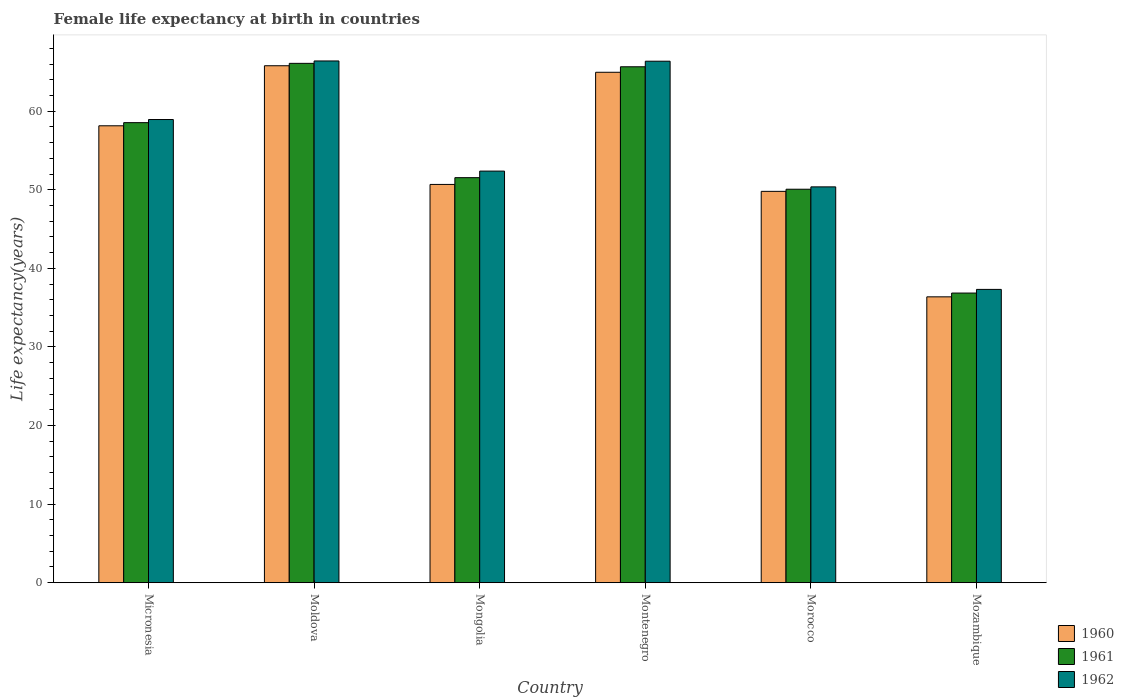How many bars are there on the 3rd tick from the right?
Your answer should be very brief. 3. What is the label of the 6th group of bars from the left?
Offer a very short reply. Mozambique. In how many cases, is the number of bars for a given country not equal to the number of legend labels?
Provide a short and direct response. 0. What is the female life expectancy at birth in 1962 in Moldova?
Your response must be concise. 66.4. Across all countries, what is the maximum female life expectancy at birth in 1962?
Your answer should be very brief. 66.4. Across all countries, what is the minimum female life expectancy at birth in 1960?
Make the answer very short. 36.38. In which country was the female life expectancy at birth in 1961 maximum?
Make the answer very short. Moldova. In which country was the female life expectancy at birth in 1960 minimum?
Your answer should be compact. Mozambique. What is the total female life expectancy at birth in 1961 in the graph?
Offer a very short reply. 328.79. What is the difference between the female life expectancy at birth in 1960 in Mongolia and that in Morocco?
Your response must be concise. 0.88. What is the difference between the female life expectancy at birth in 1960 in Micronesia and the female life expectancy at birth in 1961 in Montenegro?
Make the answer very short. -7.51. What is the average female life expectancy at birth in 1961 per country?
Keep it short and to the point. 54.8. What is the difference between the female life expectancy at birth of/in 1961 and female life expectancy at birth of/in 1962 in Montenegro?
Your response must be concise. -0.71. In how many countries, is the female life expectancy at birth in 1961 greater than 66 years?
Offer a very short reply. 1. What is the ratio of the female life expectancy at birth in 1960 in Micronesia to that in Montenegro?
Your answer should be compact. 0.9. Is the female life expectancy at birth in 1960 in Morocco less than that in Mozambique?
Make the answer very short. No. Is the difference between the female life expectancy at birth in 1961 in Micronesia and Mozambique greater than the difference between the female life expectancy at birth in 1962 in Micronesia and Mozambique?
Ensure brevity in your answer.  Yes. What is the difference between the highest and the second highest female life expectancy at birth in 1960?
Make the answer very short. -0.83. What is the difference between the highest and the lowest female life expectancy at birth in 1962?
Ensure brevity in your answer.  29.07. What does the 1st bar from the right in Mozambique represents?
Offer a terse response. 1962. Is it the case that in every country, the sum of the female life expectancy at birth in 1961 and female life expectancy at birth in 1960 is greater than the female life expectancy at birth in 1962?
Your answer should be very brief. Yes. How many bars are there?
Your response must be concise. 18. Are all the bars in the graph horizontal?
Provide a succinct answer. No. What is the difference between two consecutive major ticks on the Y-axis?
Offer a very short reply. 10. Are the values on the major ticks of Y-axis written in scientific E-notation?
Make the answer very short. No. Where does the legend appear in the graph?
Your response must be concise. Bottom right. What is the title of the graph?
Make the answer very short. Female life expectancy at birth in countries. What is the label or title of the X-axis?
Ensure brevity in your answer.  Country. What is the label or title of the Y-axis?
Give a very brief answer. Life expectancy(years). What is the Life expectancy(years) in 1960 in Micronesia?
Offer a very short reply. 58.15. What is the Life expectancy(years) of 1961 in Micronesia?
Provide a succinct answer. 58.55. What is the Life expectancy(years) of 1962 in Micronesia?
Keep it short and to the point. 58.95. What is the Life expectancy(years) in 1960 in Moldova?
Your response must be concise. 65.79. What is the Life expectancy(years) of 1961 in Moldova?
Offer a terse response. 66.1. What is the Life expectancy(years) of 1962 in Moldova?
Your response must be concise. 66.4. What is the Life expectancy(years) of 1960 in Mongolia?
Ensure brevity in your answer.  50.69. What is the Life expectancy(years) of 1961 in Mongolia?
Provide a short and direct response. 51.55. What is the Life expectancy(years) of 1962 in Mongolia?
Offer a very short reply. 52.38. What is the Life expectancy(years) in 1960 in Montenegro?
Ensure brevity in your answer.  64.96. What is the Life expectancy(years) in 1961 in Montenegro?
Give a very brief answer. 65.66. What is the Life expectancy(years) of 1962 in Montenegro?
Your response must be concise. 66.37. What is the Life expectancy(years) of 1960 in Morocco?
Give a very brief answer. 49.81. What is the Life expectancy(years) of 1961 in Morocco?
Give a very brief answer. 50.08. What is the Life expectancy(years) of 1962 in Morocco?
Give a very brief answer. 50.38. What is the Life expectancy(years) in 1960 in Mozambique?
Your answer should be very brief. 36.38. What is the Life expectancy(years) in 1961 in Mozambique?
Your answer should be very brief. 36.86. What is the Life expectancy(years) of 1962 in Mozambique?
Ensure brevity in your answer.  37.33. Across all countries, what is the maximum Life expectancy(years) of 1960?
Make the answer very short. 65.79. Across all countries, what is the maximum Life expectancy(years) of 1961?
Make the answer very short. 66.1. Across all countries, what is the maximum Life expectancy(years) in 1962?
Make the answer very short. 66.4. Across all countries, what is the minimum Life expectancy(years) in 1960?
Ensure brevity in your answer.  36.38. Across all countries, what is the minimum Life expectancy(years) of 1961?
Make the answer very short. 36.86. Across all countries, what is the minimum Life expectancy(years) of 1962?
Your response must be concise. 37.33. What is the total Life expectancy(years) in 1960 in the graph?
Give a very brief answer. 325.78. What is the total Life expectancy(years) of 1961 in the graph?
Keep it short and to the point. 328.79. What is the total Life expectancy(years) of 1962 in the graph?
Your answer should be compact. 331.8. What is the difference between the Life expectancy(years) of 1960 in Micronesia and that in Moldova?
Provide a succinct answer. -7.64. What is the difference between the Life expectancy(years) of 1961 in Micronesia and that in Moldova?
Offer a very short reply. -7.55. What is the difference between the Life expectancy(years) of 1962 in Micronesia and that in Moldova?
Make the answer very short. -7.45. What is the difference between the Life expectancy(years) of 1960 in Micronesia and that in Mongolia?
Your answer should be very brief. 7.46. What is the difference between the Life expectancy(years) of 1961 in Micronesia and that in Mongolia?
Give a very brief answer. 7. What is the difference between the Life expectancy(years) of 1962 in Micronesia and that in Mongolia?
Your response must be concise. 6.56. What is the difference between the Life expectancy(years) of 1960 in Micronesia and that in Montenegro?
Give a very brief answer. -6.81. What is the difference between the Life expectancy(years) in 1961 in Micronesia and that in Montenegro?
Ensure brevity in your answer.  -7.11. What is the difference between the Life expectancy(years) in 1962 in Micronesia and that in Montenegro?
Ensure brevity in your answer.  -7.42. What is the difference between the Life expectancy(years) of 1960 in Micronesia and that in Morocco?
Give a very brief answer. 8.34. What is the difference between the Life expectancy(years) of 1961 in Micronesia and that in Morocco?
Keep it short and to the point. 8.47. What is the difference between the Life expectancy(years) in 1962 in Micronesia and that in Morocco?
Ensure brevity in your answer.  8.57. What is the difference between the Life expectancy(years) in 1960 in Micronesia and that in Mozambique?
Ensure brevity in your answer.  21.77. What is the difference between the Life expectancy(years) in 1961 in Micronesia and that in Mozambique?
Ensure brevity in your answer.  21.69. What is the difference between the Life expectancy(years) of 1962 in Micronesia and that in Mozambique?
Offer a terse response. 21.62. What is the difference between the Life expectancy(years) of 1960 in Moldova and that in Mongolia?
Offer a very short reply. 15.1. What is the difference between the Life expectancy(years) of 1961 in Moldova and that in Mongolia?
Make the answer very short. 14.55. What is the difference between the Life expectancy(years) in 1962 in Moldova and that in Mongolia?
Your answer should be very brief. 14.02. What is the difference between the Life expectancy(years) in 1960 in Moldova and that in Montenegro?
Your response must be concise. 0.83. What is the difference between the Life expectancy(years) of 1961 in Moldova and that in Montenegro?
Provide a short and direct response. 0.43. What is the difference between the Life expectancy(years) of 1962 in Moldova and that in Montenegro?
Your answer should be very brief. 0.03. What is the difference between the Life expectancy(years) in 1960 in Moldova and that in Morocco?
Ensure brevity in your answer.  15.98. What is the difference between the Life expectancy(years) in 1961 in Moldova and that in Morocco?
Your answer should be compact. 16.02. What is the difference between the Life expectancy(years) of 1962 in Moldova and that in Morocco?
Keep it short and to the point. 16.02. What is the difference between the Life expectancy(years) in 1960 in Moldova and that in Mozambique?
Your answer should be compact. 29.41. What is the difference between the Life expectancy(years) in 1961 in Moldova and that in Mozambique?
Provide a short and direct response. 29.23. What is the difference between the Life expectancy(years) in 1962 in Moldova and that in Mozambique?
Provide a short and direct response. 29.07. What is the difference between the Life expectancy(years) in 1960 in Mongolia and that in Montenegro?
Make the answer very short. -14.27. What is the difference between the Life expectancy(years) in 1961 in Mongolia and that in Montenegro?
Provide a short and direct response. -14.11. What is the difference between the Life expectancy(years) of 1962 in Mongolia and that in Montenegro?
Ensure brevity in your answer.  -13.98. What is the difference between the Life expectancy(years) in 1960 in Mongolia and that in Morocco?
Make the answer very short. 0.88. What is the difference between the Life expectancy(years) in 1961 in Mongolia and that in Morocco?
Ensure brevity in your answer.  1.47. What is the difference between the Life expectancy(years) of 1962 in Mongolia and that in Morocco?
Your answer should be compact. 2.01. What is the difference between the Life expectancy(years) in 1960 in Mongolia and that in Mozambique?
Your answer should be compact. 14.31. What is the difference between the Life expectancy(years) of 1961 in Mongolia and that in Mozambique?
Your answer should be compact. 14.69. What is the difference between the Life expectancy(years) of 1962 in Mongolia and that in Mozambique?
Offer a terse response. 15.05. What is the difference between the Life expectancy(years) in 1960 in Montenegro and that in Morocco?
Offer a very short reply. 15.15. What is the difference between the Life expectancy(years) of 1961 in Montenegro and that in Morocco?
Your answer should be very brief. 15.58. What is the difference between the Life expectancy(years) of 1962 in Montenegro and that in Morocco?
Ensure brevity in your answer.  15.99. What is the difference between the Life expectancy(years) in 1960 in Montenegro and that in Mozambique?
Make the answer very short. 28.58. What is the difference between the Life expectancy(years) in 1961 in Montenegro and that in Mozambique?
Your response must be concise. 28.8. What is the difference between the Life expectancy(years) of 1962 in Montenegro and that in Mozambique?
Your answer should be very brief. 29.04. What is the difference between the Life expectancy(years) of 1960 in Morocco and that in Mozambique?
Your response must be concise. 13.43. What is the difference between the Life expectancy(years) of 1961 in Morocco and that in Mozambique?
Provide a short and direct response. 13.21. What is the difference between the Life expectancy(years) in 1962 in Morocco and that in Mozambique?
Give a very brief answer. 13.05. What is the difference between the Life expectancy(years) of 1960 in Micronesia and the Life expectancy(years) of 1961 in Moldova?
Your response must be concise. -7.95. What is the difference between the Life expectancy(years) in 1960 in Micronesia and the Life expectancy(years) in 1962 in Moldova?
Offer a very short reply. -8.25. What is the difference between the Life expectancy(years) of 1961 in Micronesia and the Life expectancy(years) of 1962 in Moldova?
Ensure brevity in your answer.  -7.85. What is the difference between the Life expectancy(years) in 1960 in Micronesia and the Life expectancy(years) in 1961 in Mongolia?
Give a very brief answer. 6.6. What is the difference between the Life expectancy(years) in 1960 in Micronesia and the Life expectancy(years) in 1962 in Mongolia?
Your response must be concise. 5.77. What is the difference between the Life expectancy(years) of 1961 in Micronesia and the Life expectancy(years) of 1962 in Mongolia?
Your answer should be compact. 6.17. What is the difference between the Life expectancy(years) in 1960 in Micronesia and the Life expectancy(years) in 1961 in Montenegro?
Offer a terse response. -7.51. What is the difference between the Life expectancy(years) of 1960 in Micronesia and the Life expectancy(years) of 1962 in Montenegro?
Provide a succinct answer. -8.22. What is the difference between the Life expectancy(years) in 1961 in Micronesia and the Life expectancy(years) in 1962 in Montenegro?
Your response must be concise. -7.82. What is the difference between the Life expectancy(years) of 1960 in Micronesia and the Life expectancy(years) of 1961 in Morocco?
Your response must be concise. 8.07. What is the difference between the Life expectancy(years) in 1960 in Micronesia and the Life expectancy(years) in 1962 in Morocco?
Provide a short and direct response. 7.77. What is the difference between the Life expectancy(years) in 1961 in Micronesia and the Life expectancy(years) in 1962 in Morocco?
Offer a very short reply. 8.17. What is the difference between the Life expectancy(years) in 1960 in Micronesia and the Life expectancy(years) in 1961 in Mozambique?
Make the answer very short. 21.29. What is the difference between the Life expectancy(years) of 1960 in Micronesia and the Life expectancy(years) of 1962 in Mozambique?
Keep it short and to the point. 20.82. What is the difference between the Life expectancy(years) of 1961 in Micronesia and the Life expectancy(years) of 1962 in Mozambique?
Offer a very short reply. 21.22. What is the difference between the Life expectancy(years) in 1960 in Moldova and the Life expectancy(years) in 1961 in Mongolia?
Offer a terse response. 14.24. What is the difference between the Life expectancy(years) in 1960 in Moldova and the Life expectancy(years) in 1962 in Mongolia?
Make the answer very short. 13.41. What is the difference between the Life expectancy(years) in 1961 in Moldova and the Life expectancy(years) in 1962 in Mongolia?
Keep it short and to the point. 13.71. What is the difference between the Life expectancy(years) of 1960 in Moldova and the Life expectancy(years) of 1961 in Montenegro?
Keep it short and to the point. 0.13. What is the difference between the Life expectancy(years) in 1960 in Moldova and the Life expectancy(years) in 1962 in Montenegro?
Your response must be concise. -0.58. What is the difference between the Life expectancy(years) of 1961 in Moldova and the Life expectancy(years) of 1962 in Montenegro?
Make the answer very short. -0.27. What is the difference between the Life expectancy(years) of 1960 in Moldova and the Life expectancy(years) of 1961 in Morocco?
Ensure brevity in your answer.  15.71. What is the difference between the Life expectancy(years) of 1960 in Moldova and the Life expectancy(years) of 1962 in Morocco?
Provide a succinct answer. 15.41. What is the difference between the Life expectancy(years) in 1961 in Moldova and the Life expectancy(years) in 1962 in Morocco?
Make the answer very short. 15.72. What is the difference between the Life expectancy(years) in 1960 in Moldova and the Life expectancy(years) in 1961 in Mozambique?
Offer a very short reply. 28.93. What is the difference between the Life expectancy(years) in 1960 in Moldova and the Life expectancy(years) in 1962 in Mozambique?
Your answer should be compact. 28.46. What is the difference between the Life expectancy(years) of 1961 in Moldova and the Life expectancy(years) of 1962 in Mozambique?
Ensure brevity in your answer.  28.77. What is the difference between the Life expectancy(years) in 1960 in Mongolia and the Life expectancy(years) in 1961 in Montenegro?
Provide a succinct answer. -14.97. What is the difference between the Life expectancy(years) of 1960 in Mongolia and the Life expectancy(years) of 1962 in Montenegro?
Provide a short and direct response. -15.68. What is the difference between the Life expectancy(years) in 1961 in Mongolia and the Life expectancy(years) in 1962 in Montenegro?
Your response must be concise. -14.82. What is the difference between the Life expectancy(years) in 1960 in Mongolia and the Life expectancy(years) in 1961 in Morocco?
Your answer should be very brief. 0.61. What is the difference between the Life expectancy(years) of 1960 in Mongolia and the Life expectancy(years) of 1962 in Morocco?
Give a very brief answer. 0.31. What is the difference between the Life expectancy(years) of 1961 in Mongolia and the Life expectancy(years) of 1962 in Morocco?
Keep it short and to the point. 1.17. What is the difference between the Life expectancy(years) in 1960 in Mongolia and the Life expectancy(years) in 1961 in Mozambique?
Make the answer very short. 13.82. What is the difference between the Life expectancy(years) in 1960 in Mongolia and the Life expectancy(years) in 1962 in Mozambique?
Provide a succinct answer. 13.36. What is the difference between the Life expectancy(years) of 1961 in Mongolia and the Life expectancy(years) of 1962 in Mozambique?
Offer a terse response. 14.22. What is the difference between the Life expectancy(years) of 1960 in Montenegro and the Life expectancy(years) of 1961 in Morocco?
Your answer should be very brief. 14.88. What is the difference between the Life expectancy(years) of 1960 in Montenegro and the Life expectancy(years) of 1962 in Morocco?
Your response must be concise. 14.59. What is the difference between the Life expectancy(years) in 1961 in Montenegro and the Life expectancy(years) in 1962 in Morocco?
Make the answer very short. 15.29. What is the difference between the Life expectancy(years) in 1960 in Montenegro and the Life expectancy(years) in 1961 in Mozambique?
Provide a succinct answer. 28.1. What is the difference between the Life expectancy(years) of 1960 in Montenegro and the Life expectancy(years) of 1962 in Mozambique?
Ensure brevity in your answer.  27.63. What is the difference between the Life expectancy(years) of 1961 in Montenegro and the Life expectancy(years) of 1962 in Mozambique?
Make the answer very short. 28.33. What is the difference between the Life expectancy(years) of 1960 in Morocco and the Life expectancy(years) of 1961 in Mozambique?
Your response must be concise. 12.94. What is the difference between the Life expectancy(years) in 1960 in Morocco and the Life expectancy(years) in 1962 in Mozambique?
Your response must be concise. 12.48. What is the difference between the Life expectancy(years) of 1961 in Morocco and the Life expectancy(years) of 1962 in Mozambique?
Your response must be concise. 12.75. What is the average Life expectancy(years) in 1960 per country?
Your answer should be compact. 54.3. What is the average Life expectancy(years) of 1961 per country?
Ensure brevity in your answer.  54.8. What is the average Life expectancy(years) in 1962 per country?
Your response must be concise. 55.3. What is the difference between the Life expectancy(years) in 1960 and Life expectancy(years) in 1961 in Micronesia?
Keep it short and to the point. -0.4. What is the difference between the Life expectancy(years) in 1960 and Life expectancy(years) in 1962 in Micronesia?
Your answer should be very brief. -0.8. What is the difference between the Life expectancy(years) in 1961 and Life expectancy(years) in 1962 in Micronesia?
Provide a short and direct response. -0.4. What is the difference between the Life expectancy(years) in 1960 and Life expectancy(years) in 1961 in Moldova?
Make the answer very short. -0.3. What is the difference between the Life expectancy(years) in 1960 and Life expectancy(years) in 1962 in Moldova?
Provide a succinct answer. -0.61. What is the difference between the Life expectancy(years) in 1961 and Life expectancy(years) in 1962 in Moldova?
Give a very brief answer. -0.3. What is the difference between the Life expectancy(years) of 1960 and Life expectancy(years) of 1961 in Mongolia?
Your response must be concise. -0.86. What is the difference between the Life expectancy(years) of 1960 and Life expectancy(years) of 1962 in Mongolia?
Ensure brevity in your answer.  -1.7. What is the difference between the Life expectancy(years) of 1961 and Life expectancy(years) of 1962 in Mongolia?
Give a very brief answer. -0.84. What is the difference between the Life expectancy(years) of 1960 and Life expectancy(years) of 1961 in Montenegro?
Offer a terse response. -0.7. What is the difference between the Life expectancy(years) in 1960 and Life expectancy(years) in 1962 in Montenegro?
Your answer should be compact. -1.41. What is the difference between the Life expectancy(years) of 1961 and Life expectancy(years) of 1962 in Montenegro?
Keep it short and to the point. -0.71. What is the difference between the Life expectancy(years) in 1960 and Life expectancy(years) in 1961 in Morocco?
Make the answer very short. -0.27. What is the difference between the Life expectancy(years) of 1960 and Life expectancy(years) of 1962 in Morocco?
Offer a very short reply. -0.57. What is the difference between the Life expectancy(years) of 1961 and Life expectancy(years) of 1962 in Morocco?
Your response must be concise. -0.3. What is the difference between the Life expectancy(years) in 1960 and Life expectancy(years) in 1961 in Mozambique?
Your response must be concise. -0.48. What is the difference between the Life expectancy(years) of 1960 and Life expectancy(years) of 1962 in Mozambique?
Give a very brief answer. -0.95. What is the difference between the Life expectancy(years) in 1961 and Life expectancy(years) in 1962 in Mozambique?
Offer a very short reply. -0.47. What is the ratio of the Life expectancy(years) in 1960 in Micronesia to that in Moldova?
Your answer should be very brief. 0.88. What is the ratio of the Life expectancy(years) of 1961 in Micronesia to that in Moldova?
Your answer should be very brief. 0.89. What is the ratio of the Life expectancy(years) of 1962 in Micronesia to that in Moldova?
Offer a very short reply. 0.89. What is the ratio of the Life expectancy(years) of 1960 in Micronesia to that in Mongolia?
Provide a succinct answer. 1.15. What is the ratio of the Life expectancy(years) in 1961 in Micronesia to that in Mongolia?
Make the answer very short. 1.14. What is the ratio of the Life expectancy(years) in 1962 in Micronesia to that in Mongolia?
Provide a short and direct response. 1.13. What is the ratio of the Life expectancy(years) of 1960 in Micronesia to that in Montenegro?
Give a very brief answer. 0.9. What is the ratio of the Life expectancy(years) of 1961 in Micronesia to that in Montenegro?
Provide a succinct answer. 0.89. What is the ratio of the Life expectancy(years) of 1962 in Micronesia to that in Montenegro?
Give a very brief answer. 0.89. What is the ratio of the Life expectancy(years) in 1960 in Micronesia to that in Morocco?
Keep it short and to the point. 1.17. What is the ratio of the Life expectancy(years) of 1961 in Micronesia to that in Morocco?
Give a very brief answer. 1.17. What is the ratio of the Life expectancy(years) in 1962 in Micronesia to that in Morocco?
Your answer should be very brief. 1.17. What is the ratio of the Life expectancy(years) in 1960 in Micronesia to that in Mozambique?
Offer a very short reply. 1.6. What is the ratio of the Life expectancy(years) in 1961 in Micronesia to that in Mozambique?
Your answer should be compact. 1.59. What is the ratio of the Life expectancy(years) of 1962 in Micronesia to that in Mozambique?
Your answer should be compact. 1.58. What is the ratio of the Life expectancy(years) of 1960 in Moldova to that in Mongolia?
Give a very brief answer. 1.3. What is the ratio of the Life expectancy(years) of 1961 in Moldova to that in Mongolia?
Provide a succinct answer. 1.28. What is the ratio of the Life expectancy(years) in 1962 in Moldova to that in Mongolia?
Keep it short and to the point. 1.27. What is the ratio of the Life expectancy(years) of 1960 in Moldova to that in Montenegro?
Your answer should be compact. 1.01. What is the ratio of the Life expectancy(years) of 1961 in Moldova to that in Montenegro?
Make the answer very short. 1.01. What is the ratio of the Life expectancy(years) in 1960 in Moldova to that in Morocco?
Provide a succinct answer. 1.32. What is the ratio of the Life expectancy(years) in 1961 in Moldova to that in Morocco?
Ensure brevity in your answer.  1.32. What is the ratio of the Life expectancy(years) in 1962 in Moldova to that in Morocco?
Your answer should be compact. 1.32. What is the ratio of the Life expectancy(years) in 1960 in Moldova to that in Mozambique?
Keep it short and to the point. 1.81. What is the ratio of the Life expectancy(years) of 1961 in Moldova to that in Mozambique?
Offer a very short reply. 1.79. What is the ratio of the Life expectancy(years) of 1962 in Moldova to that in Mozambique?
Your answer should be compact. 1.78. What is the ratio of the Life expectancy(years) of 1960 in Mongolia to that in Montenegro?
Offer a terse response. 0.78. What is the ratio of the Life expectancy(years) in 1961 in Mongolia to that in Montenegro?
Keep it short and to the point. 0.79. What is the ratio of the Life expectancy(years) in 1962 in Mongolia to that in Montenegro?
Provide a succinct answer. 0.79. What is the ratio of the Life expectancy(years) of 1960 in Mongolia to that in Morocco?
Provide a short and direct response. 1.02. What is the ratio of the Life expectancy(years) of 1961 in Mongolia to that in Morocco?
Provide a succinct answer. 1.03. What is the ratio of the Life expectancy(years) in 1962 in Mongolia to that in Morocco?
Keep it short and to the point. 1.04. What is the ratio of the Life expectancy(years) in 1960 in Mongolia to that in Mozambique?
Give a very brief answer. 1.39. What is the ratio of the Life expectancy(years) in 1961 in Mongolia to that in Mozambique?
Offer a very short reply. 1.4. What is the ratio of the Life expectancy(years) of 1962 in Mongolia to that in Mozambique?
Your answer should be compact. 1.4. What is the ratio of the Life expectancy(years) in 1960 in Montenegro to that in Morocco?
Provide a short and direct response. 1.3. What is the ratio of the Life expectancy(years) in 1961 in Montenegro to that in Morocco?
Provide a succinct answer. 1.31. What is the ratio of the Life expectancy(years) of 1962 in Montenegro to that in Morocco?
Keep it short and to the point. 1.32. What is the ratio of the Life expectancy(years) in 1960 in Montenegro to that in Mozambique?
Make the answer very short. 1.79. What is the ratio of the Life expectancy(years) of 1961 in Montenegro to that in Mozambique?
Provide a short and direct response. 1.78. What is the ratio of the Life expectancy(years) of 1962 in Montenegro to that in Mozambique?
Make the answer very short. 1.78. What is the ratio of the Life expectancy(years) in 1960 in Morocco to that in Mozambique?
Ensure brevity in your answer.  1.37. What is the ratio of the Life expectancy(years) in 1961 in Morocco to that in Mozambique?
Keep it short and to the point. 1.36. What is the ratio of the Life expectancy(years) of 1962 in Morocco to that in Mozambique?
Your answer should be compact. 1.35. What is the difference between the highest and the second highest Life expectancy(years) of 1960?
Your response must be concise. 0.83. What is the difference between the highest and the second highest Life expectancy(years) in 1961?
Your answer should be compact. 0.43. What is the difference between the highest and the second highest Life expectancy(years) of 1962?
Ensure brevity in your answer.  0.03. What is the difference between the highest and the lowest Life expectancy(years) in 1960?
Give a very brief answer. 29.41. What is the difference between the highest and the lowest Life expectancy(years) of 1961?
Your response must be concise. 29.23. What is the difference between the highest and the lowest Life expectancy(years) in 1962?
Ensure brevity in your answer.  29.07. 